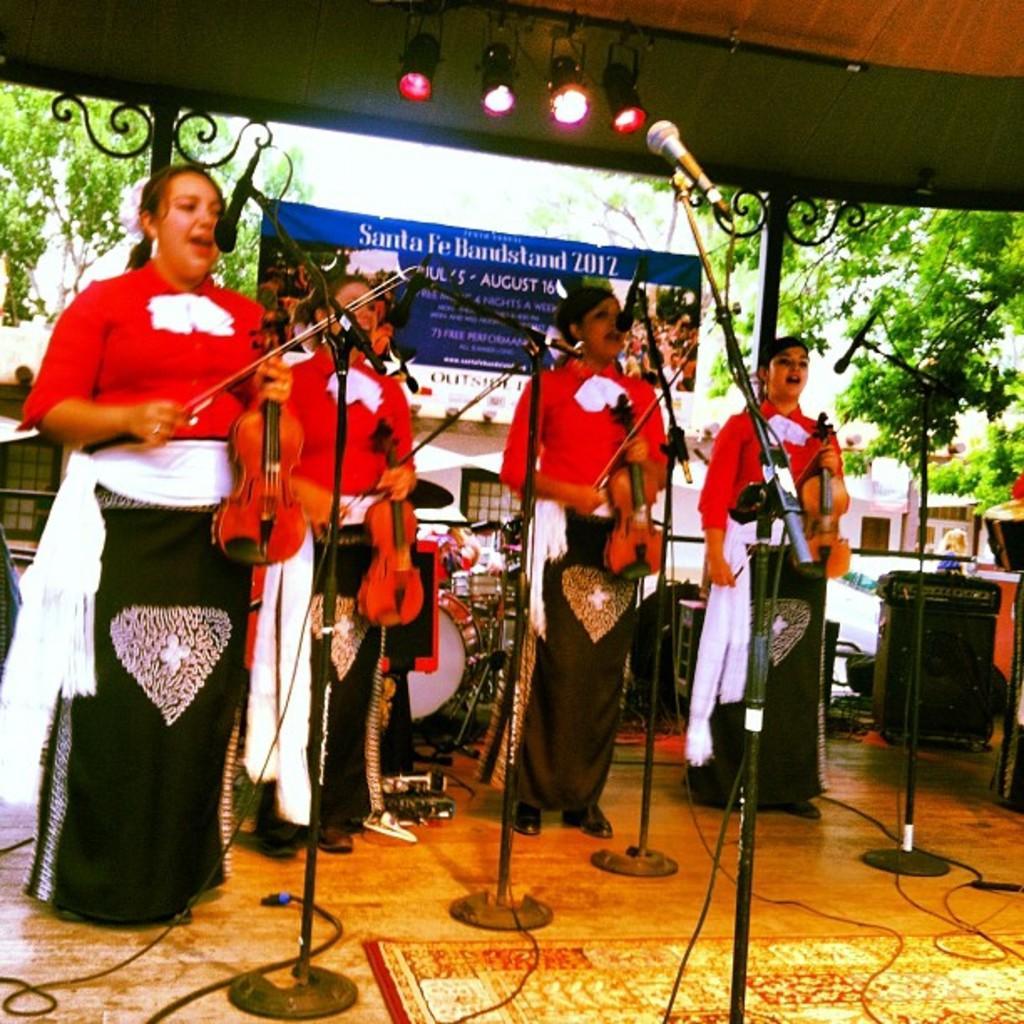Describe this image in one or two sentences. In this image we can see the four women holding the guitars and singing in front of the mike stands which are present on the stairs. We can also see the carpet, wires and also banner with text. In the background we can see the trees, buildings. We can also see the focus lights and also the roof for shelter. On the right we can see the drums. 